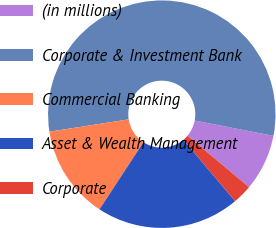<chart> <loc_0><loc_0><loc_500><loc_500><pie_chart><fcel>(in millions)<fcel>Corporate & Investment Bank<fcel>Commercial Banking<fcel>Asset & Wealth Management<fcel>Corporate<nl><fcel>8.04%<fcel>55.51%<fcel>13.31%<fcel>20.37%<fcel>2.76%<nl></chart> 